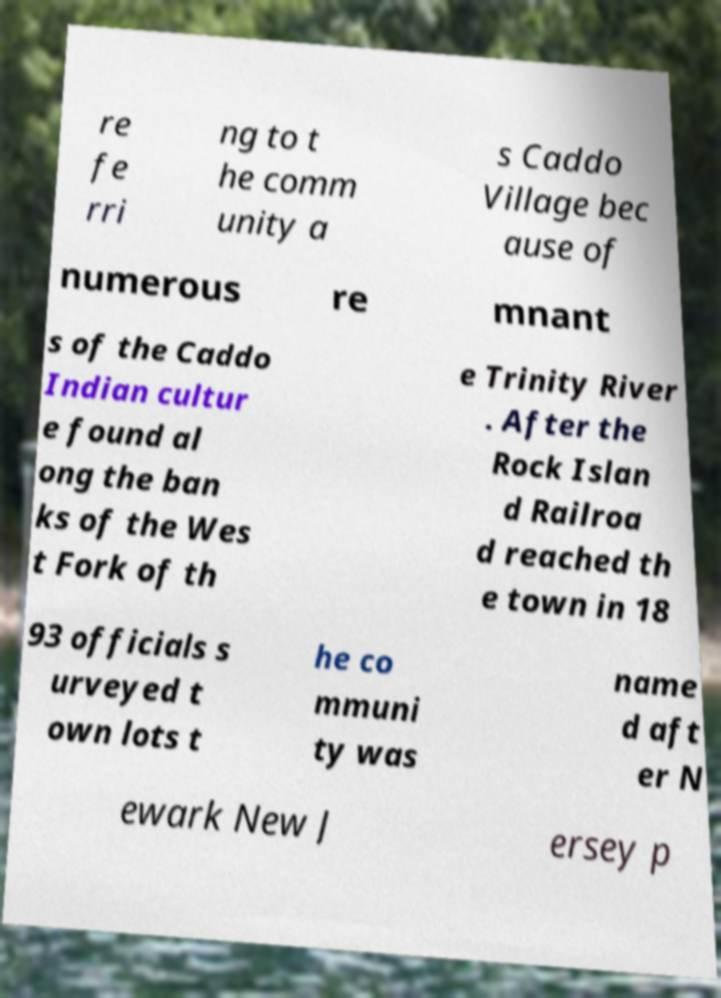There's text embedded in this image that I need extracted. Can you transcribe it verbatim? re fe rri ng to t he comm unity a s Caddo Village bec ause of numerous re mnant s of the Caddo Indian cultur e found al ong the ban ks of the Wes t Fork of th e Trinity River . After the Rock Islan d Railroa d reached th e town in 18 93 officials s urveyed t own lots t he co mmuni ty was name d aft er N ewark New J ersey p 